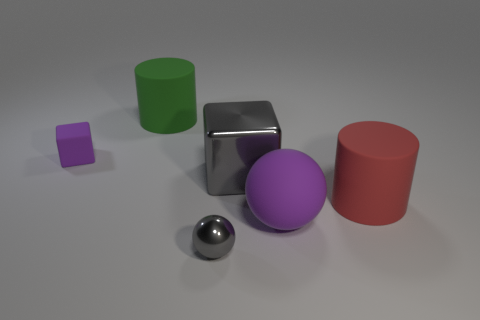Add 4 small purple things. How many objects exist? 10 Subtract all cylinders. How many objects are left? 4 Add 4 rubber cylinders. How many rubber cylinders are left? 6 Add 6 shiny spheres. How many shiny spheres exist? 7 Subtract all red cylinders. How many cylinders are left? 1 Subtract 1 gray cubes. How many objects are left? 5 Subtract 2 balls. How many balls are left? 0 Subtract all purple blocks. Subtract all brown spheres. How many blocks are left? 1 Subtract all purple balls. How many green blocks are left? 0 Subtract all metal objects. Subtract all big yellow shiny cylinders. How many objects are left? 4 